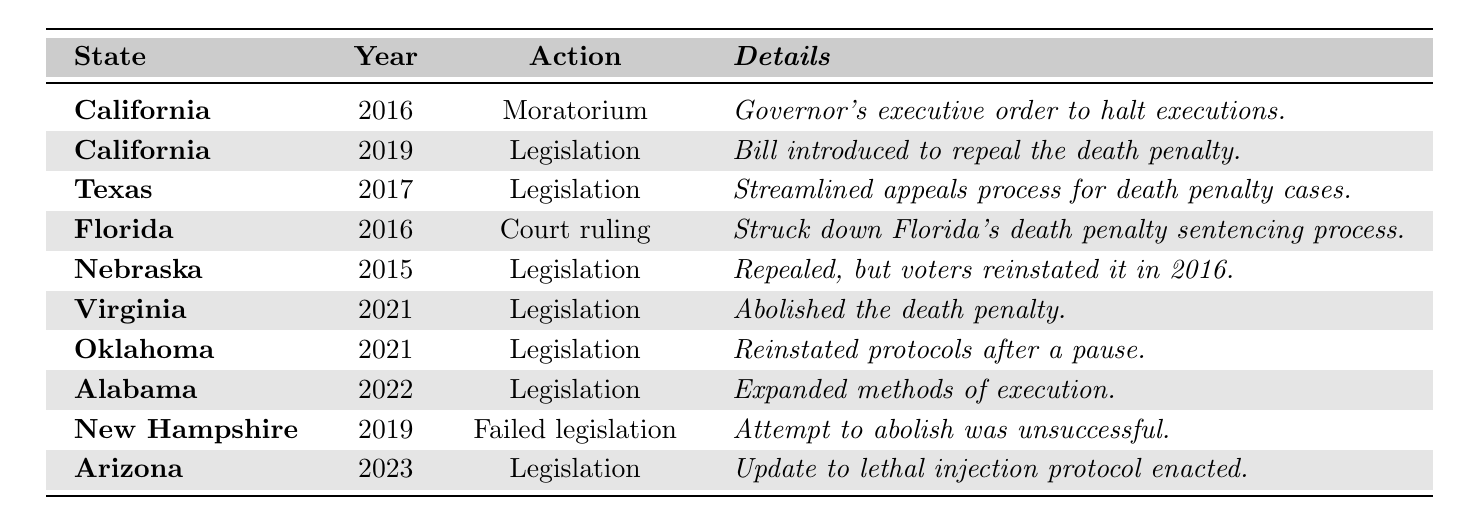What's the total number of states that abolished the death penalty since 2015? From the table, only Virginia abolished the death penalty in 2021 and Nebraska had repealed it in 2015 but was reinstated in 2016. Therefore, the total number of states that abolished it is 1.
Answer: 1 In which year did California first impose a moratorium on executions? The table states that California imposed a moratorium on executions in 2016.
Answer: 2016 How many times did legislation regarding the death penalty fail in the listed states? New Hampshire attempted to abolish the death penalty in 2019 but the legislation failed. There is only 1 instance of failed legislation in the table.
Answer: 1 Which state had legislation passed to streamline the appeals process for death penalty cases? Texas had legislation passed in 2017 to streamline the appeals process as indicated in the table.
Answer: Texas Which year saw the most states taking action related to the death penalty? By reviewing the table, in 2021, both Virginia and Oklahoma had legislation passed related to the death penalty, making it a total of 2 actions that year.
Answer: 2021 Was there any action related to the death penalty in Florida in 2016? Yes, the table shows that in 2016, Florida had a Supreme Court ruling that struck down its death penalty sentencing process.
Answer: Yes What percentage of the changes listed in the table involved states abolishing the death penalty? There are 9 total changes listed and only 1 state (Virginia) abolished it. Thus, the percentage is (1/9)*100 = 11.11%.
Answer: Approximately 11% Which state re-instituted its death penalty protocols after a pause? According to the table, Oklahoma reinstated its death penalty protocols in 2021.
Answer: Oklahoma How many states expanded methods of execution in the last decade? The table indicates that Alabama expanded methods of execution in 2022, which is the only instance listed.
Answer: 1 What was the response of California regarding the death penalty in 2019? California introduced legislation to repeal the death penalty in 2019, as stated in the table.
Answer: Repeal legislation introduced 